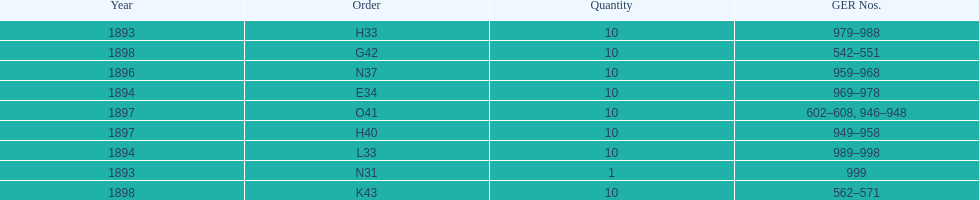In which year was the quantity greater, 1894 or 1893? 1894. Write the full table. {'header': ['Year', 'Order', 'Quantity', 'GER Nos.'], 'rows': [['1893', 'H33', '10', '979–988'], ['1898', 'G42', '10', '542–551'], ['1896', 'N37', '10', '959–968'], ['1894', 'E34', '10', '969–978'], ['1897', 'O41', '10', '602–608, 946–948'], ['1897', 'H40', '10', '949–958'], ['1894', 'L33', '10', '989–998'], ['1893', 'N31', '1', '999'], ['1898', 'K43', '10', '562–571']]} 